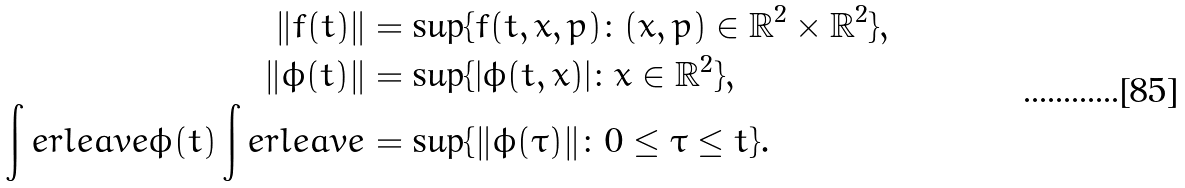<formula> <loc_0><loc_0><loc_500><loc_500>\| f ( t ) \| & = \sup \{ f ( t , x , p ) \colon ( x , p ) \in \mathbb { R } ^ { 2 } \times \mathbb { R } ^ { 2 } \} , \\ \| \phi ( t ) \| & = \sup \{ | \phi ( t , x ) | \colon x \in \mathbb { R } ^ { 2 } \} , \\ \int e r l e a v e \phi ( t ) \int e r l e a v e & = \sup \{ \| \phi ( \tau ) \| \colon 0 \leq \tau \leq t \} .</formula> 